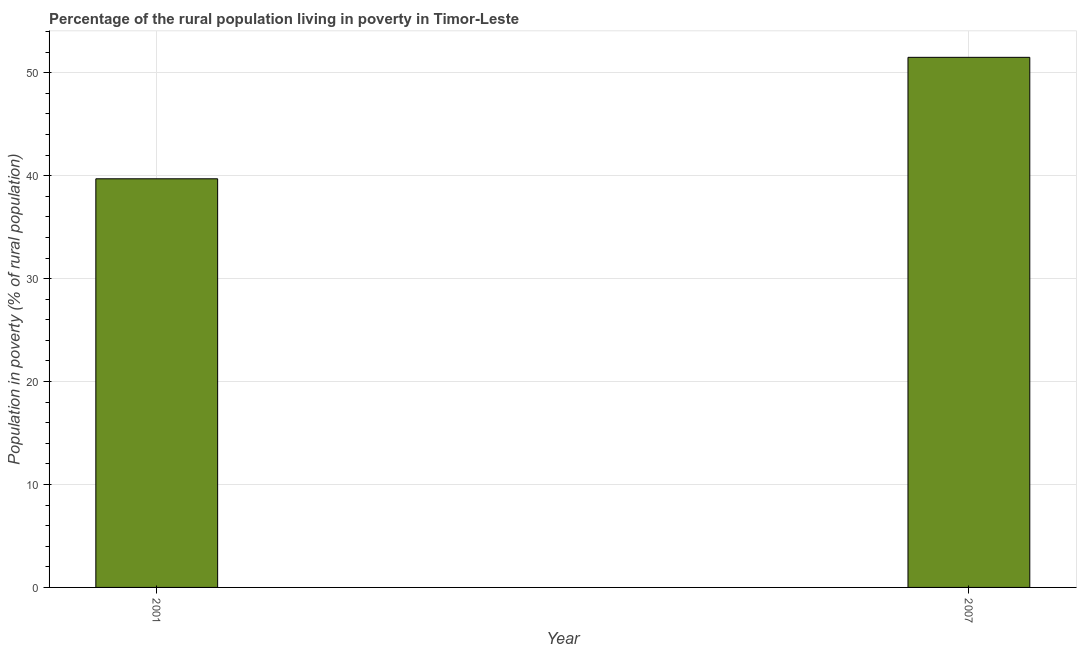Does the graph contain any zero values?
Your answer should be compact. No. What is the title of the graph?
Keep it short and to the point. Percentage of the rural population living in poverty in Timor-Leste. What is the label or title of the X-axis?
Keep it short and to the point. Year. What is the label or title of the Y-axis?
Your answer should be very brief. Population in poverty (% of rural population). What is the percentage of rural population living below poverty line in 2007?
Give a very brief answer. 51.5. Across all years, what is the maximum percentage of rural population living below poverty line?
Offer a very short reply. 51.5. Across all years, what is the minimum percentage of rural population living below poverty line?
Provide a short and direct response. 39.7. In which year was the percentage of rural population living below poverty line maximum?
Your answer should be compact. 2007. In which year was the percentage of rural population living below poverty line minimum?
Your response must be concise. 2001. What is the sum of the percentage of rural population living below poverty line?
Offer a very short reply. 91.2. What is the average percentage of rural population living below poverty line per year?
Provide a succinct answer. 45.6. What is the median percentage of rural population living below poverty line?
Give a very brief answer. 45.6. In how many years, is the percentage of rural population living below poverty line greater than 12 %?
Give a very brief answer. 2. What is the ratio of the percentage of rural population living below poverty line in 2001 to that in 2007?
Provide a short and direct response. 0.77. Is the percentage of rural population living below poverty line in 2001 less than that in 2007?
Provide a short and direct response. Yes. What is the difference between two consecutive major ticks on the Y-axis?
Offer a very short reply. 10. What is the Population in poverty (% of rural population) in 2001?
Keep it short and to the point. 39.7. What is the Population in poverty (% of rural population) of 2007?
Give a very brief answer. 51.5. What is the difference between the Population in poverty (% of rural population) in 2001 and 2007?
Make the answer very short. -11.8. What is the ratio of the Population in poverty (% of rural population) in 2001 to that in 2007?
Offer a very short reply. 0.77. 